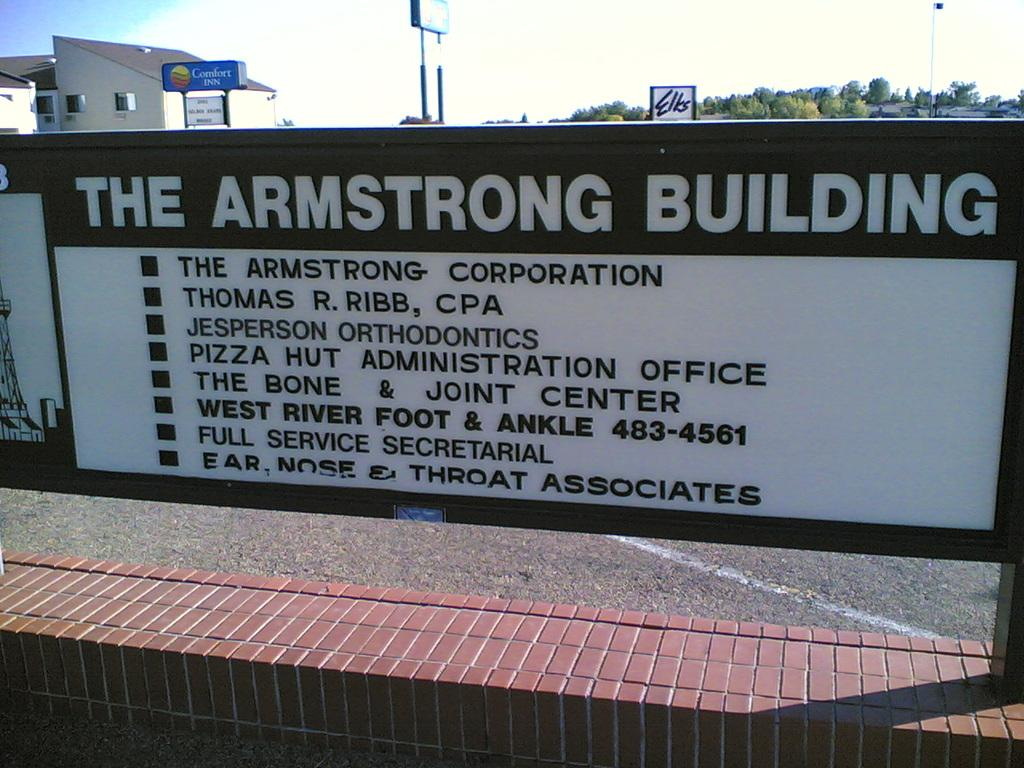<image>
Render a clear and concise summary of the photo. The Armstrong Building with a directory and a Comfort Inn hotel in back of it. 